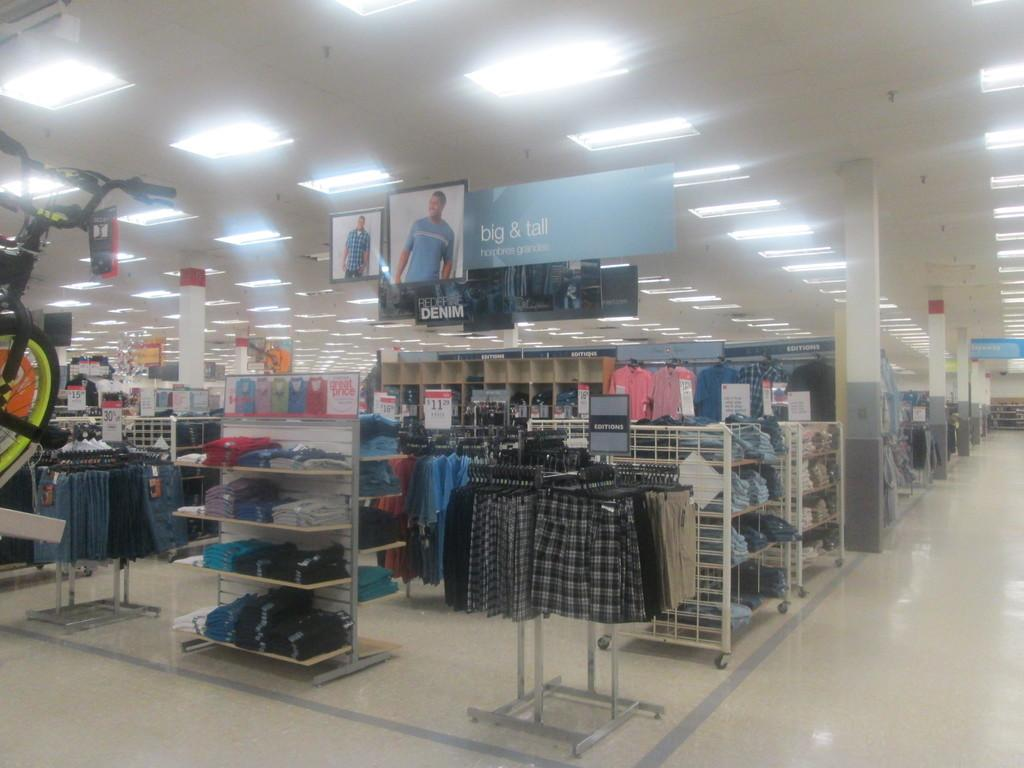Provide a one-sentence caption for the provided image. The big and tall section of a store that is brightly lit. 